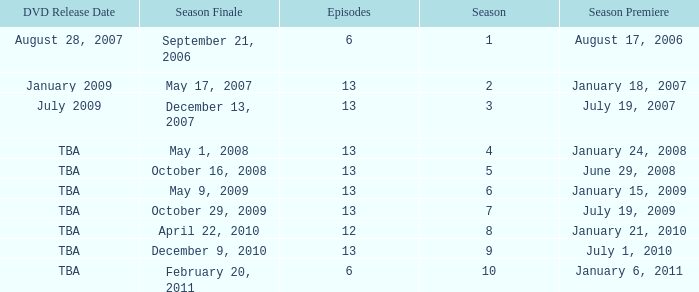On what date was the DVD released for the season with fewer than 13 episodes that aired before season 8? August 28, 2007. 